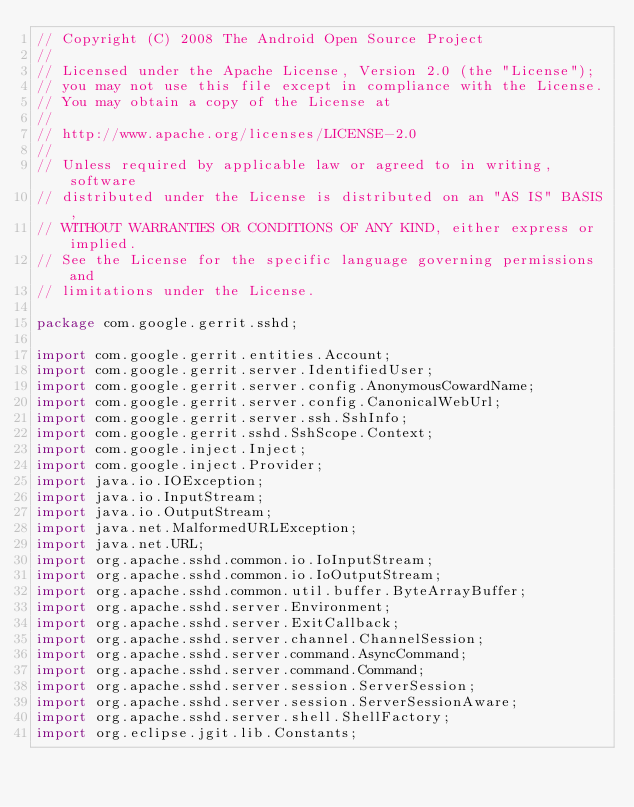Convert code to text. <code><loc_0><loc_0><loc_500><loc_500><_Java_>// Copyright (C) 2008 The Android Open Source Project
//
// Licensed under the Apache License, Version 2.0 (the "License");
// you may not use this file except in compliance with the License.
// You may obtain a copy of the License at
//
// http://www.apache.org/licenses/LICENSE-2.0
//
// Unless required by applicable law or agreed to in writing, software
// distributed under the License is distributed on an "AS IS" BASIS,
// WITHOUT WARRANTIES OR CONDITIONS OF ANY KIND, either express or implied.
// See the License for the specific language governing permissions and
// limitations under the License.

package com.google.gerrit.sshd;

import com.google.gerrit.entities.Account;
import com.google.gerrit.server.IdentifiedUser;
import com.google.gerrit.server.config.AnonymousCowardName;
import com.google.gerrit.server.config.CanonicalWebUrl;
import com.google.gerrit.server.ssh.SshInfo;
import com.google.gerrit.sshd.SshScope.Context;
import com.google.inject.Inject;
import com.google.inject.Provider;
import java.io.IOException;
import java.io.InputStream;
import java.io.OutputStream;
import java.net.MalformedURLException;
import java.net.URL;
import org.apache.sshd.common.io.IoInputStream;
import org.apache.sshd.common.io.IoOutputStream;
import org.apache.sshd.common.util.buffer.ByteArrayBuffer;
import org.apache.sshd.server.Environment;
import org.apache.sshd.server.ExitCallback;
import org.apache.sshd.server.channel.ChannelSession;
import org.apache.sshd.server.command.AsyncCommand;
import org.apache.sshd.server.command.Command;
import org.apache.sshd.server.session.ServerSession;
import org.apache.sshd.server.session.ServerSessionAware;
import org.apache.sshd.server.shell.ShellFactory;
import org.eclipse.jgit.lib.Constants;</code> 